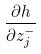Convert formula to latex. <formula><loc_0><loc_0><loc_500><loc_500>\frac { \partial h } { \partial z _ { j } ^ { - } }</formula> 